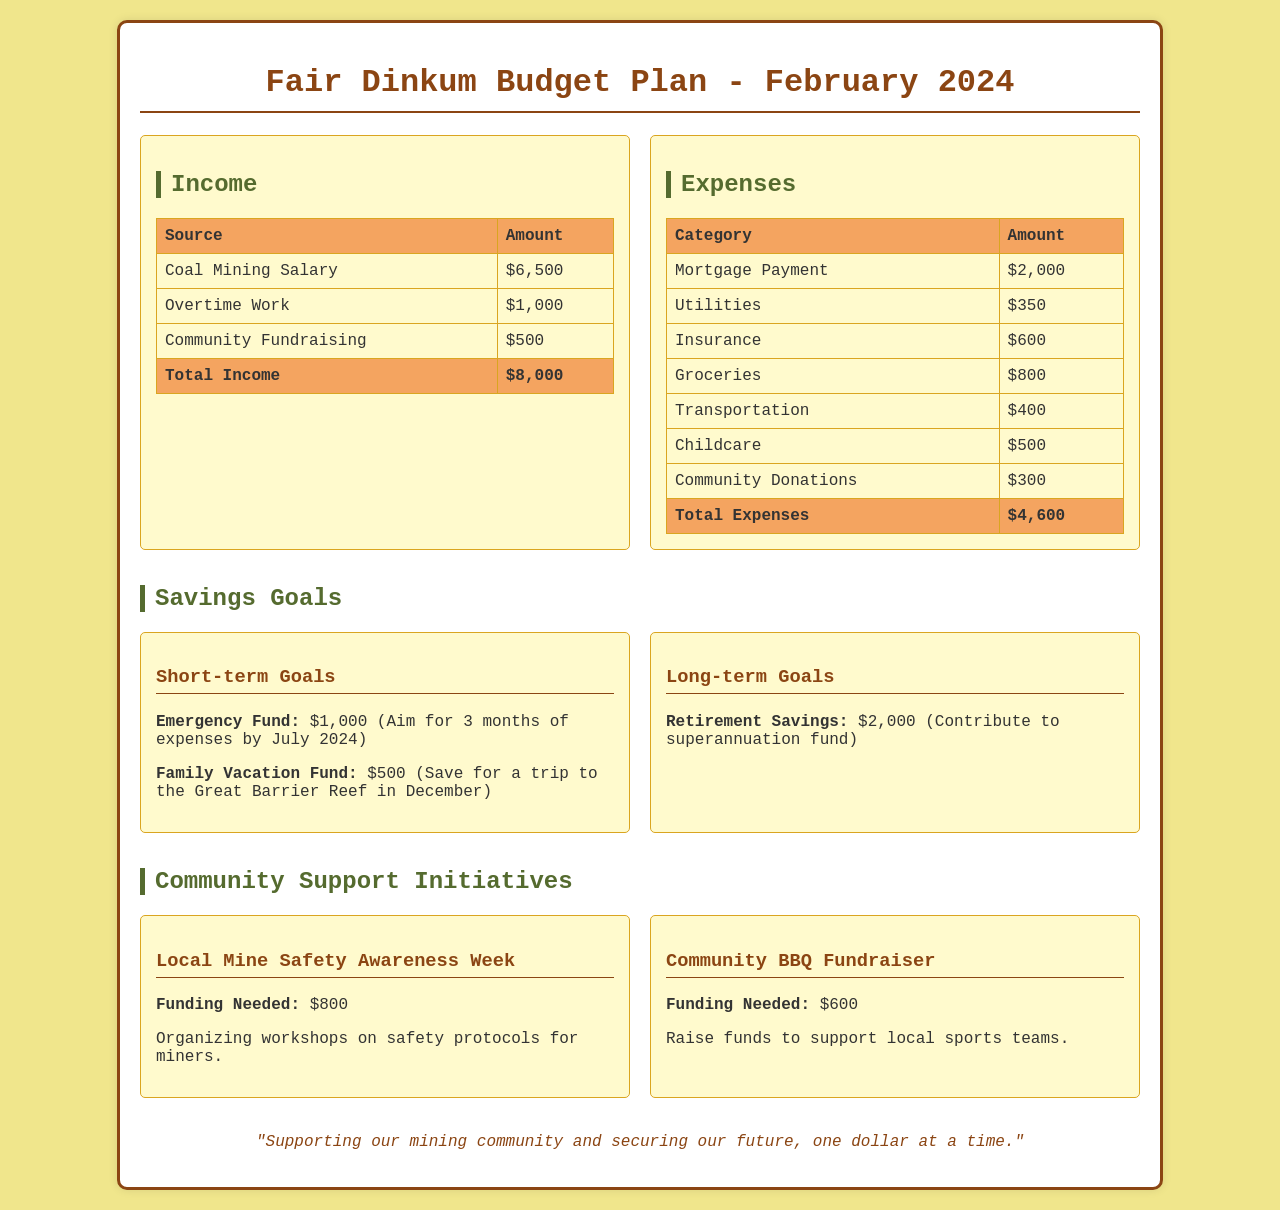What is the total income for February 2024? The total income is the sum of all income sources listed in the document, which are Coal Mining Salary, Overtime Work, and Community Fundraising.
Answer: $8,000 What is the amount allocated for groceries? The amount for groceries is specified under expenses in the document.
Answer: $800 How much is needed for the Local Mine Safety Awareness Week? The funding needed for this community initiative is provided in the document.
Answer: $800 What is the total amount of expenses listed? The total expenses are the sum of all expense categories detailed in the document.
Answer: $4,600 What is the goal for the Emergency Fund by July 2024? The document mentions an aim for the Emergency Fund that requires reasoning about months of expenses.
Answer: 3 months of expenses What is the funding required for the Community BBQ Fundraiser? The required funding for this specific initiative is outlined in the document.
Answer: $600 How much is being saved for the Family Vacation Fund? The amount allocated for family vacation savings can be found in the savings goals section of the document.
Answer: $500 What is the total amount saved toward retirement savings? This refers to the contribution specified within the long-term savings goals in the document.
Answer: $2,000 What month is targeted for the Family Vacation? The document states an intended month for the Family Vacation in the savings goals.
Answer: December 